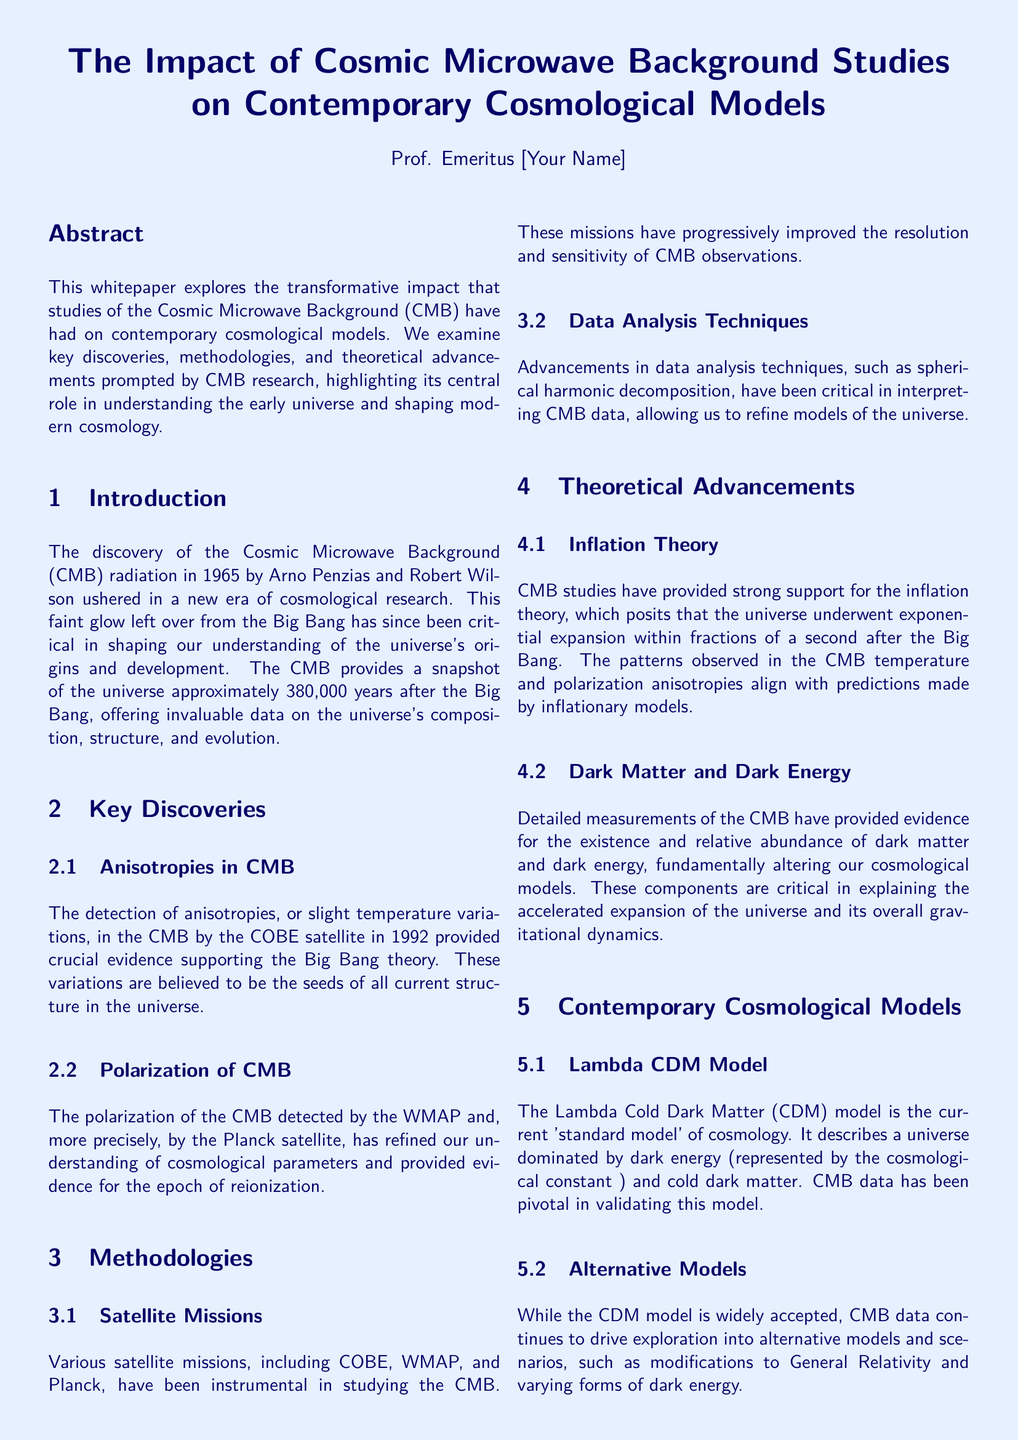What significant evidence did the COBE satellite provide? The COBE satellite detected anisotropies in the CMB, which are essential for supporting the Big Bang theory.
Answer: Anisotropies Which satellite missions have improved CMB observations? The missions include COBE, WMAP, and Planck, which have progressively enhanced resolution and sensitivity.
Answer: COBE, WMAP, Planck What theory is strongly supported by CMB studies? CMB studies support inflation theory, which suggests exponential expansion of the universe just after the Big Bang.
Answer: Inflation theory What is the current standard model of cosmology? The Lambda Cold Dark Matter (ΛCDM) model describes a universe dominated by dark energy and cold dark matter.
Answer: Lambda Cold Dark Matter (ΛCDM) model What crucial components do detailed CMB measurements indicate? CMB measurements reveal the existence and relative abundance of dark matter and dark energy.
Answer: Dark matter and dark energy What future missions are mentioned for CMB research? Upcoming missions include the Simons Observatory and the CMB-S4 experiment, which aim to refine our understanding.
Answer: Simons Observatory, CMB-S4 What is the role of polarization in CMB studies? Polarization provides evidence for the epoch of reionization and refines cosmological parameters.
Answer: Evidence for the epoch of reionization Who discovered the Cosmic Microwave Background radiation? The CMB radiation was discovered by Arno Penzias and Robert Wilson in 1965.
Answer: Arno Penzias and Robert Wilson What data analysis technique is mentioned in the methodologies section? Spherical harmonic decomposition is a key data analysis technique used in interpreting CMB data.
Answer: Spherical harmonic decomposition 